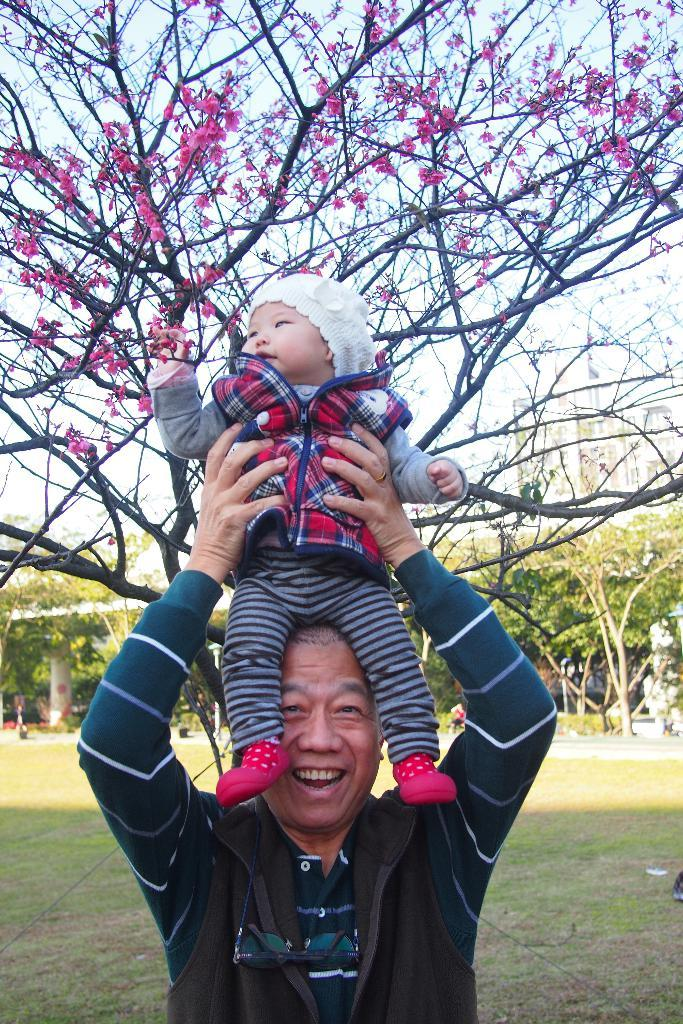What is the person in the image doing with the kid? The person is holding a kid in the image. What type of vegetation is present in the image? There are trees and grass in the image. What can be seen in the background of the image? There is a building and the sky visible in the background of the image. What decision did the person make regarding their throat in the image? There is no mention of a throat or any decision-making process in the image. 